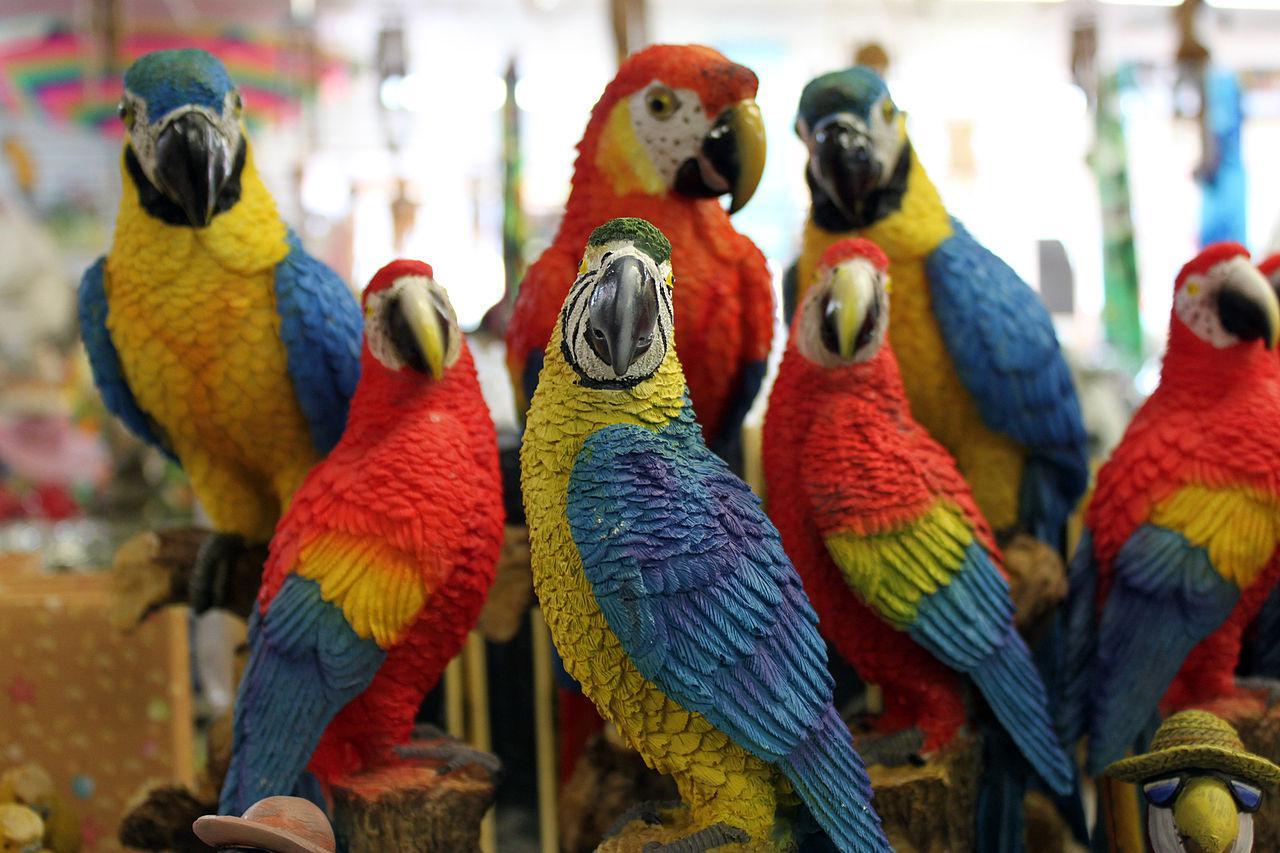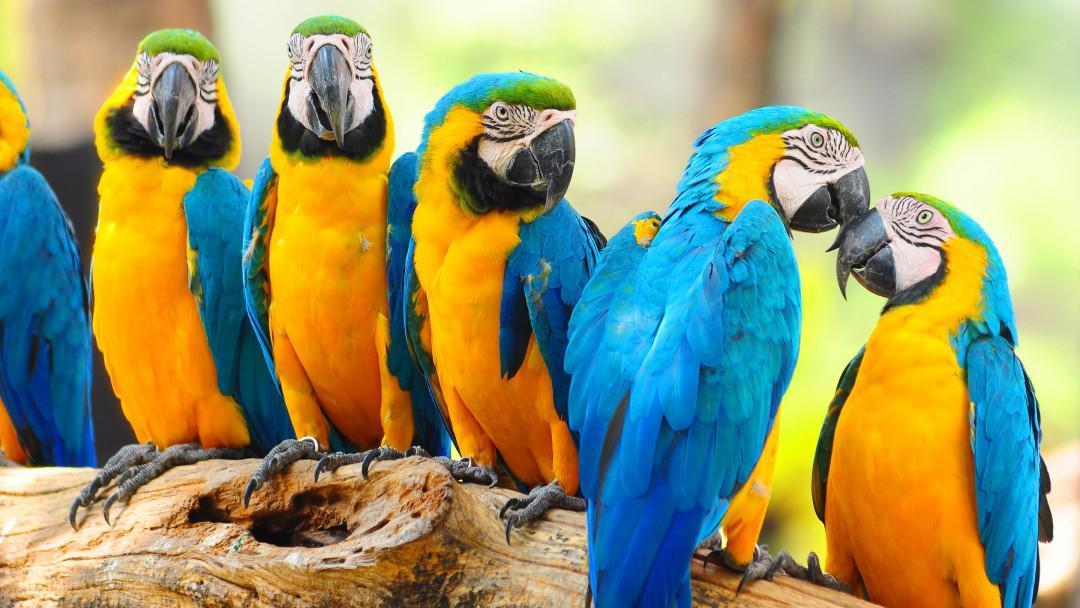The first image is the image on the left, the second image is the image on the right. For the images displayed, is the sentence "At least one image contains no more than 3 birds." factually correct? Answer yes or no. No. 